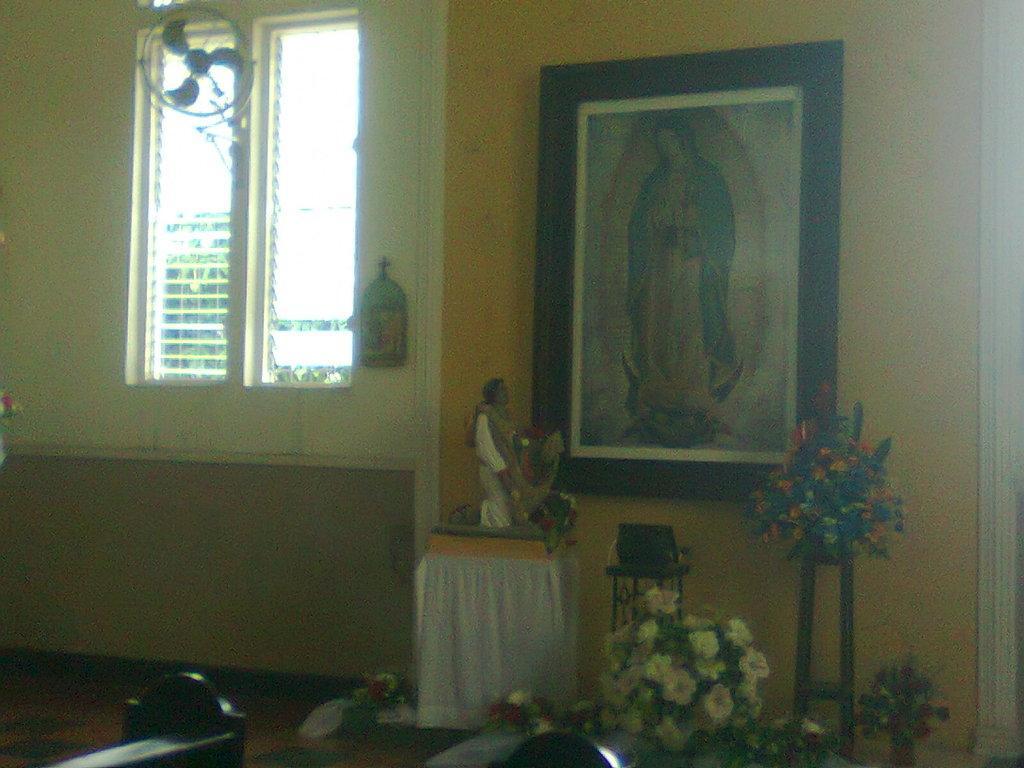In one or two sentences, can you explain what this image depicts? In this image I can see the cream colored wall, few flowers which are white, red and orange in color, a photo frame attached to the yellow colored surface, the floor and the window through which I can see few trees. 